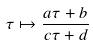<formula> <loc_0><loc_0><loc_500><loc_500>\tau \mapsto \frac { a \tau + b } { c \tau + d }</formula> 